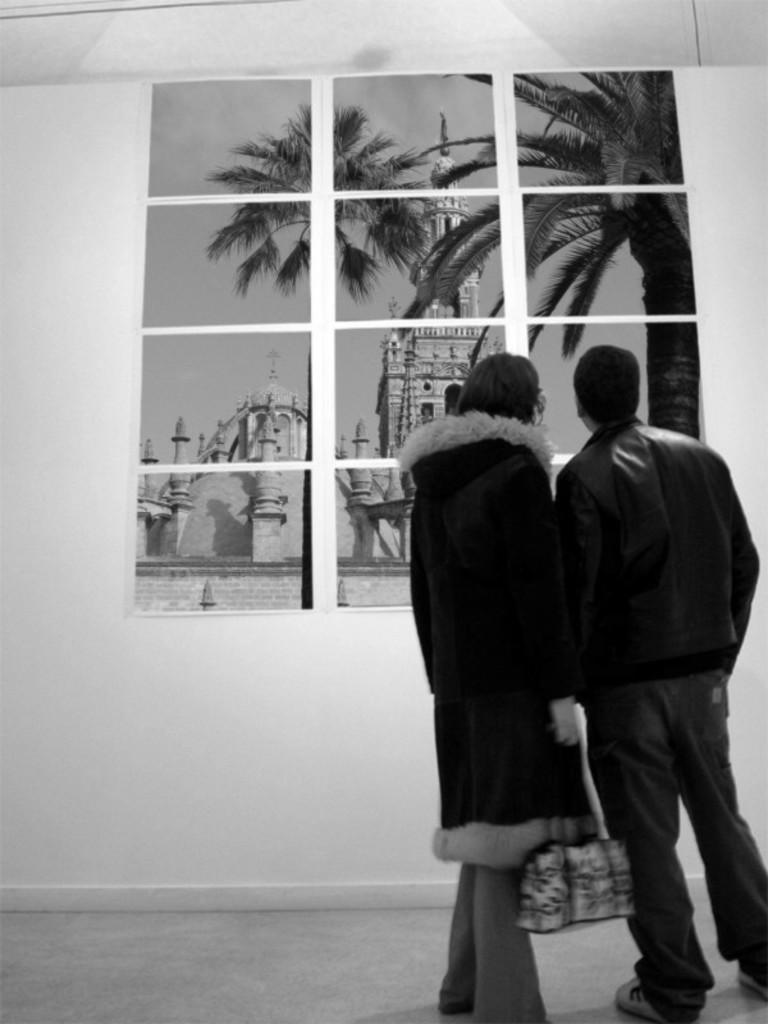How many people are present in the image? There are two people standing in the image. What is one person holding? One person is holding a bag. What can be seen in front of the people? There is a wall with images in front of the people. What type of teeth can be seen in the image? There are no teeth visible in the image. Can you describe the chair that the people are sitting on? There is no chair present in the image; the people are standing. 